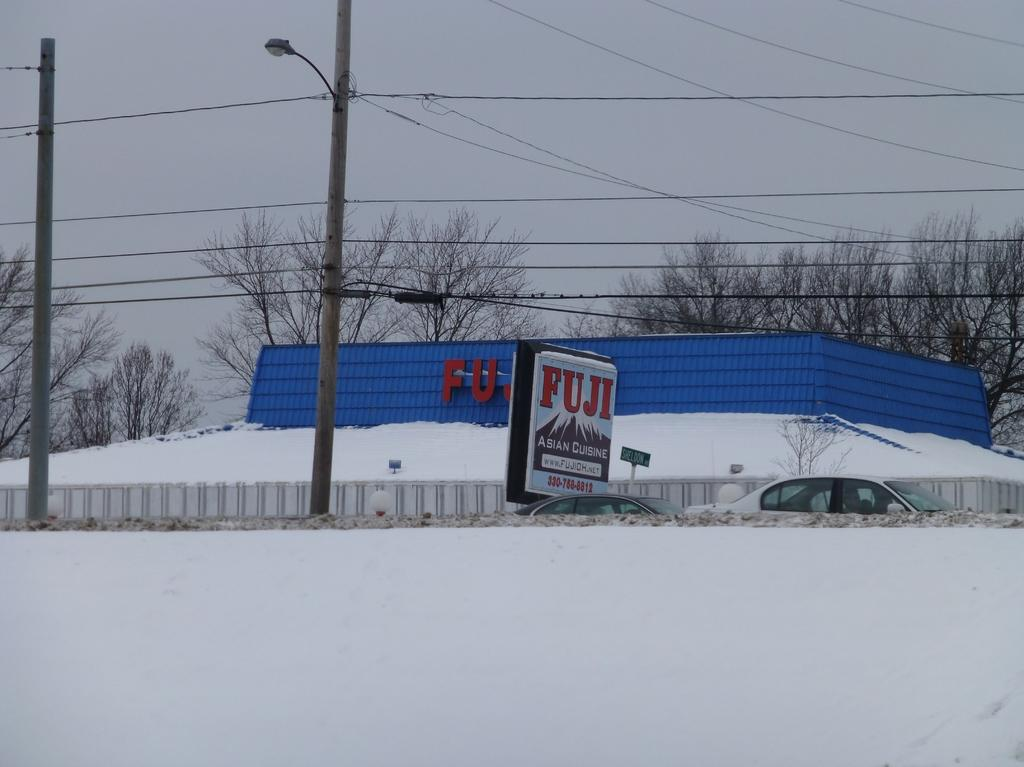<image>
Offer a succinct explanation of the picture presented. FUJI store covered in snow on a cloudy day. 